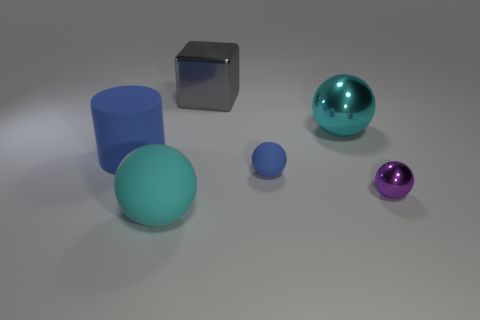Subtract all blue matte balls. How many balls are left? 3 Subtract all purple cylinders. How many cyan balls are left? 2 Subtract all purple balls. How many balls are left? 3 Add 4 yellow spheres. How many objects exist? 10 Subtract all purple balls. Subtract all green cylinders. How many balls are left? 3 Add 2 metallic spheres. How many metallic spheres exist? 4 Subtract 0 blue blocks. How many objects are left? 6 Subtract all balls. How many objects are left? 2 Subtract all large rubber balls. Subtract all metallic objects. How many objects are left? 2 Add 4 big cyan shiny objects. How many big cyan shiny objects are left? 5 